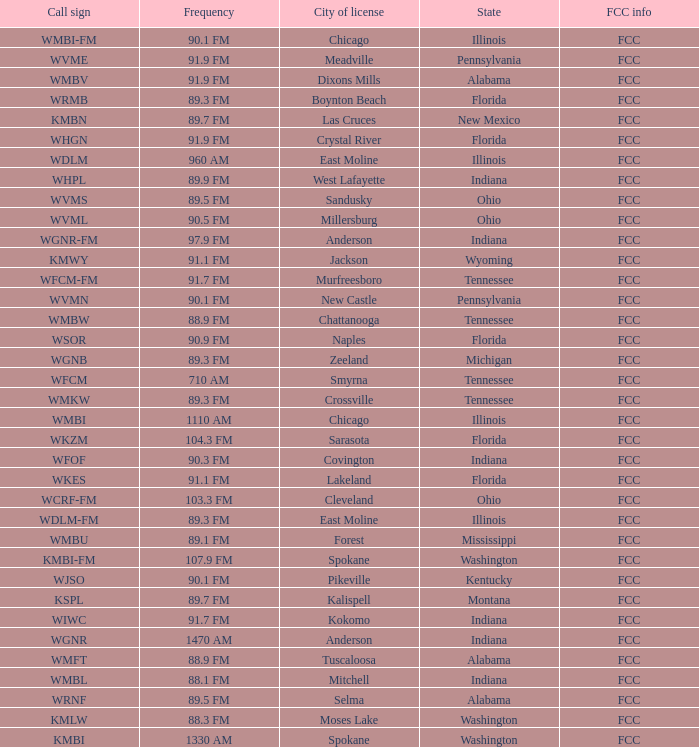What is the frequency of the radio station with a call sign of WGNR-FM? 97.9 FM. 